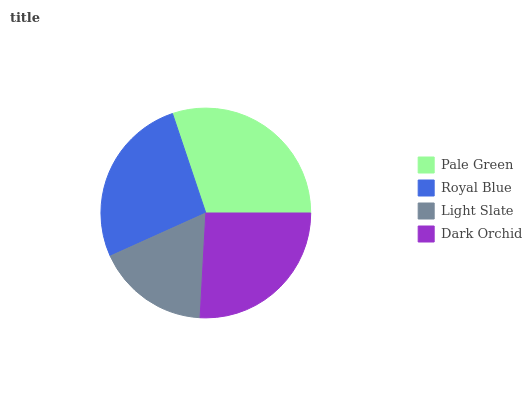Is Light Slate the minimum?
Answer yes or no. Yes. Is Pale Green the maximum?
Answer yes or no. Yes. Is Royal Blue the minimum?
Answer yes or no. No. Is Royal Blue the maximum?
Answer yes or no. No. Is Pale Green greater than Royal Blue?
Answer yes or no. Yes. Is Royal Blue less than Pale Green?
Answer yes or no. Yes. Is Royal Blue greater than Pale Green?
Answer yes or no. No. Is Pale Green less than Royal Blue?
Answer yes or no. No. Is Royal Blue the high median?
Answer yes or no. Yes. Is Dark Orchid the low median?
Answer yes or no. Yes. Is Dark Orchid the high median?
Answer yes or no. No. Is Light Slate the low median?
Answer yes or no. No. 